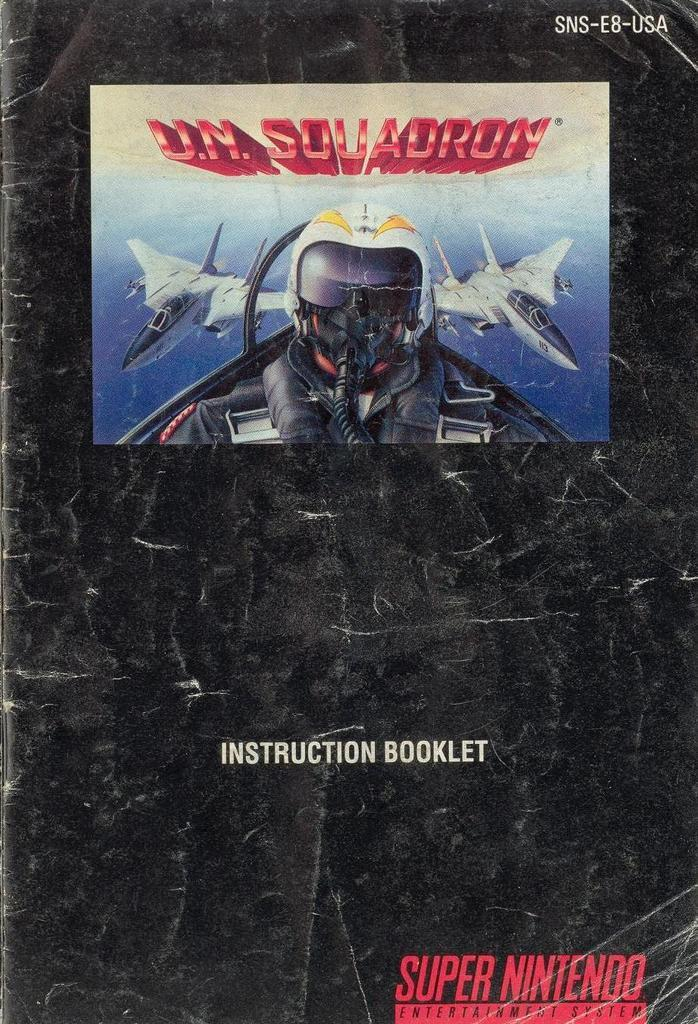<image>
Offer a succinct explanation of the picture presented. The cover of an instruction booklet for a Super Nintendo game shows a pilot. 